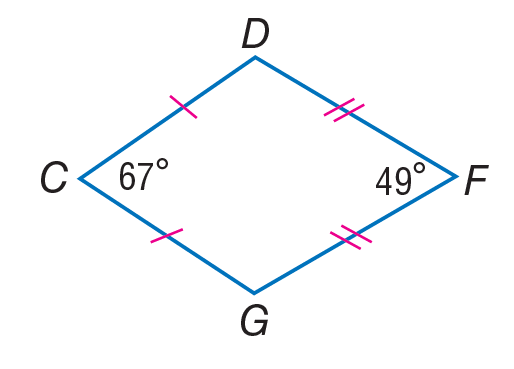Answer the mathemtical geometry problem and directly provide the correct option letter.
Question: If C D F G is a kite, find m \angle D.
Choices: A: 18 B: 49 C: 67 D: 122 D 